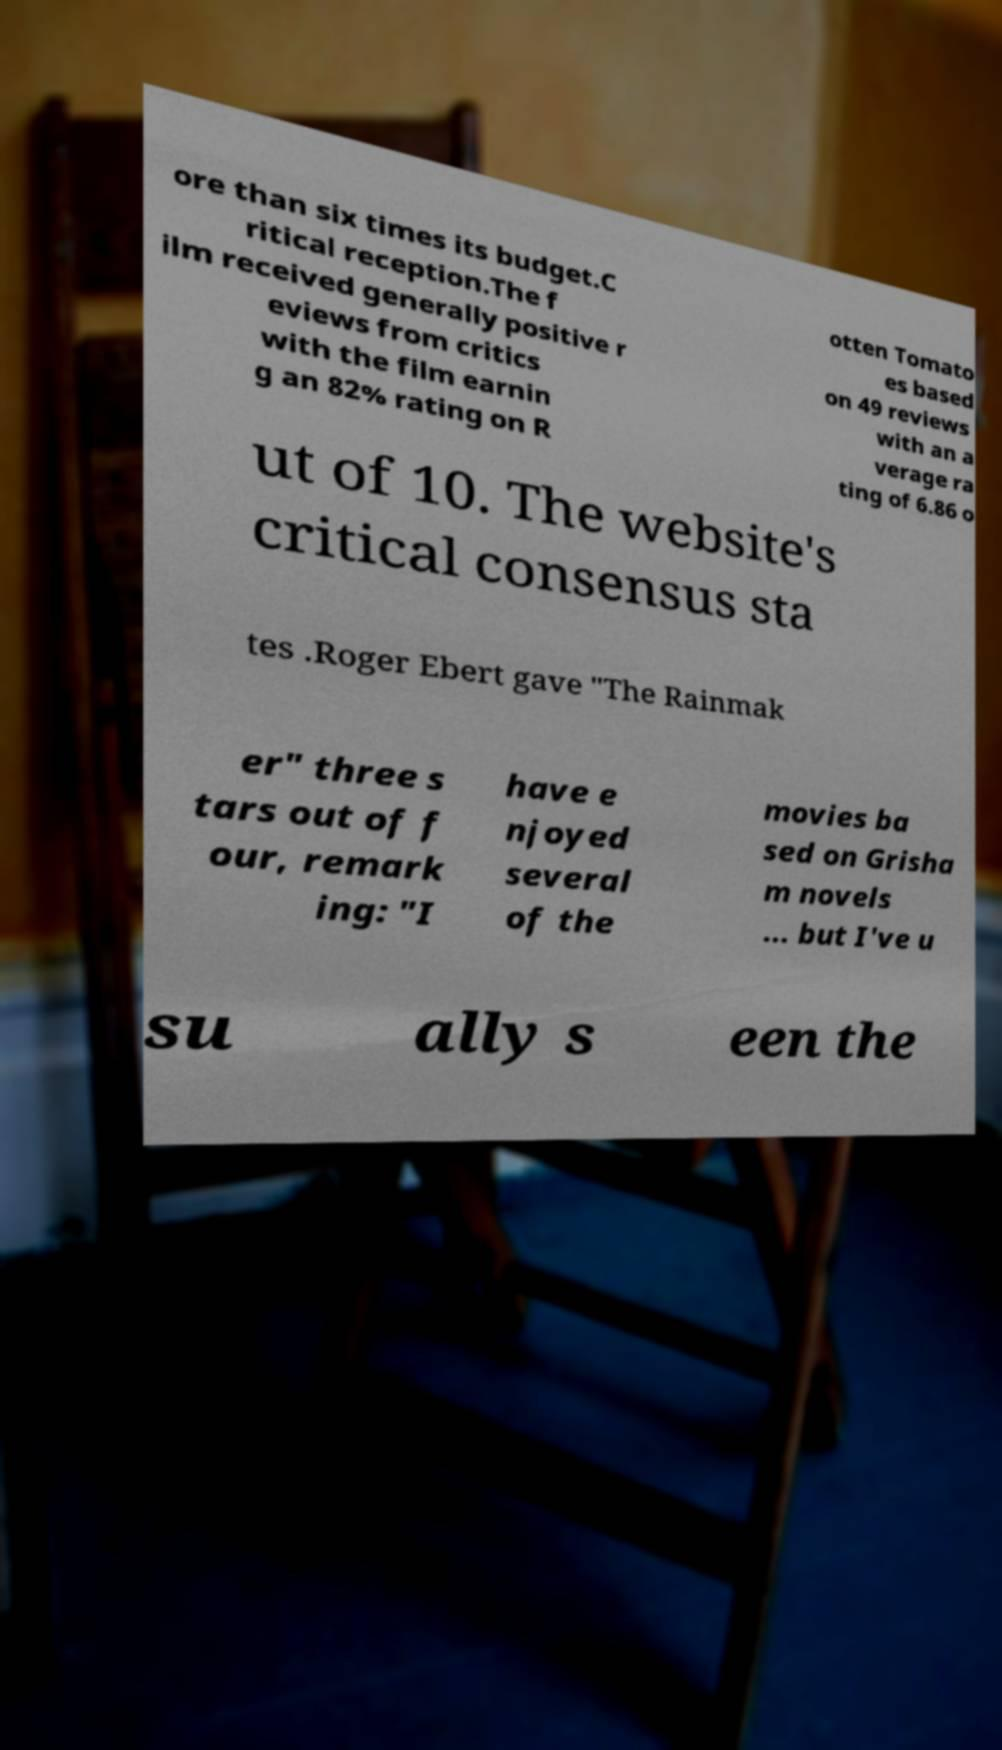Could you extract and type out the text from this image? ore than six times its budget.C ritical reception.The f ilm received generally positive r eviews from critics with the film earnin g an 82% rating on R otten Tomato es based on 49 reviews with an a verage ra ting of 6.86 o ut of 10. The website's critical consensus sta tes .Roger Ebert gave "The Rainmak er" three s tars out of f our, remark ing: "I have e njoyed several of the movies ba sed on Grisha m novels ... but I've u su ally s een the 